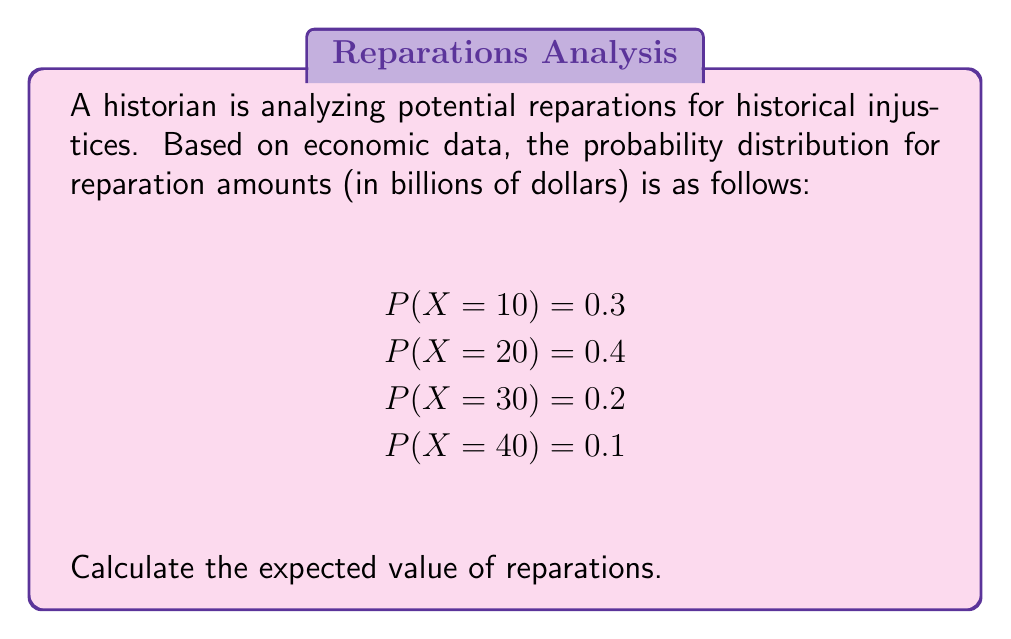Provide a solution to this math problem. To calculate the expected value of a discrete random variable, we use the formula:

$$E(X) = \sum_{i=1}^{n} x_i \cdot P(X = x_i)$$

Where $x_i$ are the possible values of X, and $P(X = x_i)$ is the probability of X taking on that value.

Let's calculate each term:

1. $10 \cdot P(X = 10) = 10 \cdot 0.3 = 3$
2. $20 \cdot P(X = 20) = 20 \cdot 0.4 = 8$
3. $30 \cdot P(X = 30) = 30 \cdot 0.2 = 6$
4. $40 \cdot P(X = 40) = 40 \cdot 0.1 = 4$

Now, sum all these terms:

$$E(X) = 3 + 8 + 6 + 4 = 21$$

Therefore, the expected value of reparations is 21 billion dollars.
Answer: $21 billion 